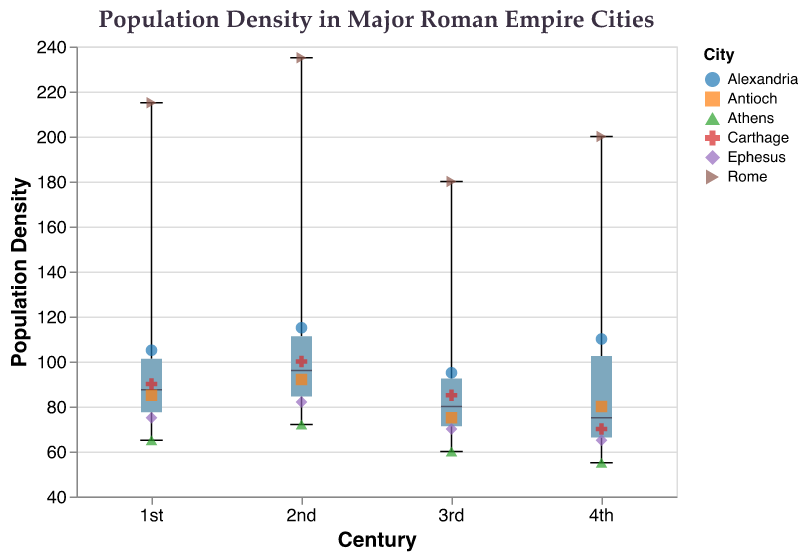What is the title of the figure? The title of the figure is displayed at the top, and it reads "Population Density in Major Roman Empire Cities".
Answer: Population Density in Major Roman Empire Cities Which century has the highest median population density? To determine the century with the highest median population density, inspect the centers of the box plots along the y-axis. The 2nd century shows the highest median value.
Answer: 2nd century What is the population density of Rome in the 1st century? By looking at the scatter points colored and shaped specifically for each city, we find Rome's data point on the 1st century's x-coordinate. The population density is 215.
Answer: 215 Which city shows the highest population density at any century? Compare all the scatter points across centuries. The highest population density seen is Rome in the 2nd century at a value of 235.
Answer: Rome What trend can you observe in Athens' population density over the centuries? To ascertain the trend, trace the scatter points for Athens from the 1st to the 4th century. The population density consistently decreases from 65 to 55.
Answer: Decreasing trend Which city had the least population density in the 4th century? Inspect scatter points at the x-coordinate for the 4th century. Athens shows the lowest population density at 55.
Answer: Athens What is the median population density in the 1st century? The median is marked by a thicker line in the box plot for each century. In the 1st century, this line is approximately at 105.
Answer: 105 How does Antioch’s population density change from the 1st to the 3rd century? Track the scatter points for Antioch across these centuries. The population density decreases from 85 to 75.
Answer: Decreases Which century shows the largest interquartile range (IQR) for population densities? The IQR is the length of the box in the box plot. The 2nd century has the largest box, indicating the largest IQR.
Answer: 2nd century Is the population density of Alexandria in the 3rd century below or above the overall median line of the 1st century? Compare Alexandria's population density of 95 in the 3rd century to the 1st century's median of 105. It is below 105.
Answer: Below 